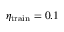Convert formula to latex. <formula><loc_0><loc_0><loc_500><loc_500>\eta _ { t r a i n } = 0 . 1</formula> 